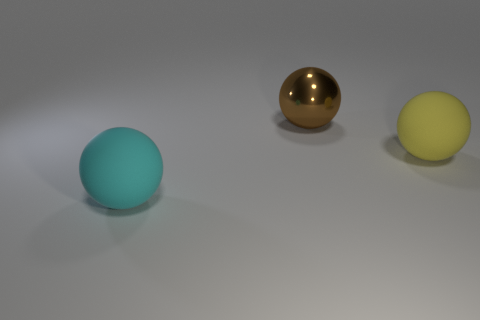Do the cyan matte thing and the thing behind the yellow matte thing have the same size?
Offer a terse response. Yes. There is a large rubber object that is to the left of the big metal sphere; what is its shape?
Make the answer very short. Sphere. Is there a cyan thing that is to the left of the large matte object that is behind the large rubber thing that is to the left of the yellow sphere?
Your response must be concise. Yes. What material is the brown thing that is the same shape as the cyan rubber thing?
Make the answer very short. Metal. Is there anything else that is made of the same material as the large brown ball?
Offer a terse response. No. How many spheres are either yellow objects or brown objects?
Provide a succinct answer. 2. There is a rubber object on the left side of the big brown metal thing; is it the same size as the thing that is to the right of the brown metallic thing?
Give a very brief answer. Yes. What is the large brown ball that is right of the cyan sphere that is in front of the shiny thing made of?
Offer a very short reply. Metal. Is the number of shiny things that are to the left of the big shiny thing less than the number of big spheres?
Ensure brevity in your answer.  Yes. What is the shape of the other thing that is made of the same material as the big yellow object?
Ensure brevity in your answer.  Sphere. 